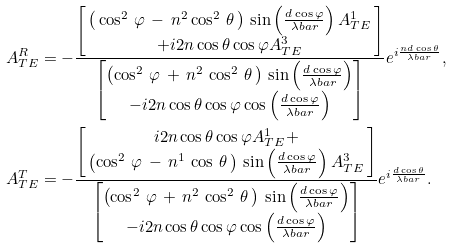Convert formula to latex. <formula><loc_0><loc_0><loc_500><loc_500>A ^ { R } _ { T E } & = - \frac { \begin{bmatrix} \, \left ( \, \cos ^ { 2 } \, \varphi \, - \, n ^ { 2 } \cos ^ { 2 } \, \theta \, \right ) \, \sin \left ( \frac { d \cos \varphi } { \lambda b a r } \right ) A ^ { 1 } _ { T E } \, \\ + i 2 n \cos \theta \cos \varphi A ^ { 3 } _ { T E } \end{bmatrix} } { \begin{bmatrix} \left ( \cos ^ { 2 } \, \varphi \, + \, n ^ { 2 } \, \cos ^ { 2 } \, \theta \, \right ) \, \sin \left ( \frac { d \cos \varphi } { \lambda b a r } \right ) \\ - i 2 n \cos \theta \cos \varphi \cos \left ( \frac { d \cos \varphi } { \lambda b a r } \right ) \end{bmatrix} } e ^ { i \frac { n d \cos \theta } { \lambda b a r } } , \\ A ^ { T } _ { T E } & = - \frac { \begin{bmatrix} i 2 n \cos \theta \cos \varphi A ^ { 1 } _ { T E } + \\ \, \left ( \cos ^ { 2 } \, \varphi \, - \, n ^ { 1 } \, \cos \, \theta \, \right ) \, \sin \left ( \frac { d \cos \varphi } { \lambda b a r } \right ) A ^ { 3 } _ { T E } \, \end{bmatrix} } { \begin{bmatrix} \left ( \cos ^ { 2 } \, \varphi \, + \, n ^ { 2 } \, \cos ^ { 2 } \, \theta \, \right ) \, \sin \left ( \frac { d \cos \varphi } { \lambda b a r } \right ) \\ - i 2 n \cos \theta \cos \varphi \cos \left ( \frac { d \cos \varphi } { \lambda b a r } \right ) \end{bmatrix} } e ^ { i \frac { d \cos \theta } { \lambda b a r } } .</formula> 